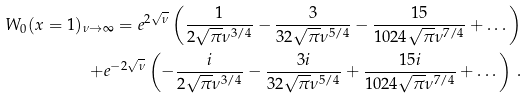<formula> <loc_0><loc_0><loc_500><loc_500>W _ { 0 } ( x = 1 ) _ { \nu \to \infty } = e ^ { 2 \sqrt { \nu } } \left ( \frac { 1 } { 2 \sqrt { \pi } \nu ^ { 3 / 4 } } - \frac { 3 } { 3 2 \sqrt { \pi } \nu ^ { 5 / 4 } } - \frac { 1 5 } { 1 0 2 4 \sqrt { \pi } \nu ^ { 7 / 4 } } + \dots \right ) \\ + e ^ { - 2 \sqrt { \nu } } \left ( - \frac { i } { 2 \sqrt { \pi } \nu ^ { 3 / 4 } } - \frac { 3 i } { 3 2 \sqrt { \pi } \nu ^ { 5 / 4 } } + \frac { 1 5 i } { 1 0 2 4 \sqrt { \pi } \nu ^ { 7 / 4 } } + \dots \right ) \, .</formula> 